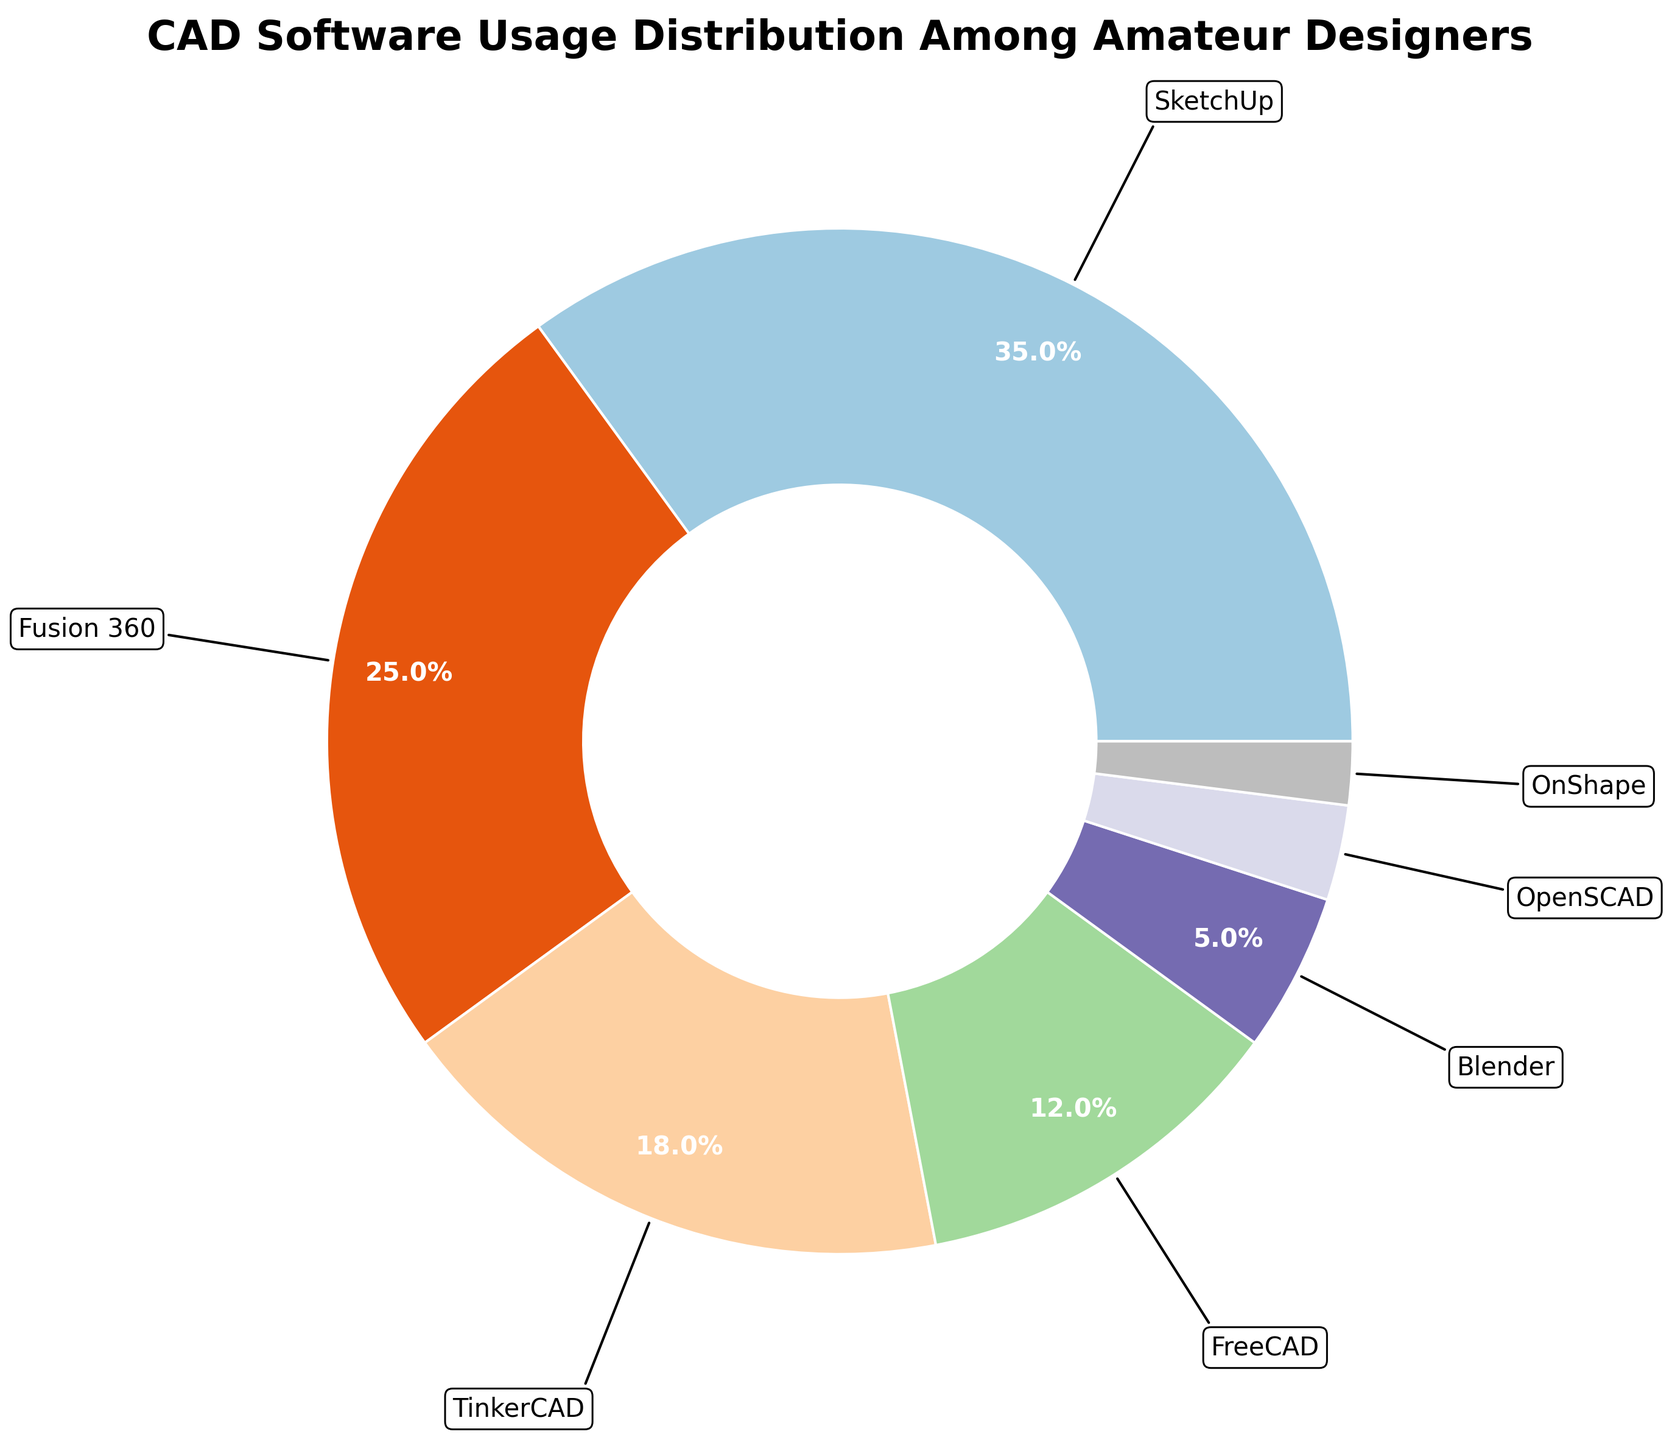How much higher is the percentage of SketchUp users than Blender users? To find out how much higher the SketchUp percentage is than the Blender percentage, subtract Blender's percentage (5%) from SketchUp's percentage (35%). So, 35% - 5% = 30%.
Answer: 30% Which software has the lowest usage percentage among amateur designers? Identify the software with the smallest slice in the pie chart. The smallest slice is for OnShape, with a usage percentage of 2%.
Answer: OnShape What is the combined percentage usage of TinkerCAD and FreeCAD? Add the usage percentages of TinkerCAD and FreeCAD: 18% + 12% = 30%.
Answer: 30% How does the usage of Fusion 360 compare to that of SketchUp? Compare the percentages directly from the pie chart: Fusion 360 has a 25% usage, while SketchUp has a 35% usage. Fusion 360's usage is 10% less than SketchUp's.
Answer: Fusion 360 is 10% less Is the usage of FreeCAD greater than OpenSCAD and OnShape combined? First, calculate the combined percentage of OpenSCAD and OnShape: 3% + 2% = 5%. Then compare it to FreeCAD's 12%. Since 12% is greater than 5%, FreeCAD's usage is indeed higher.
Answer: Yes What is the total percentage usage of software other than SketchUp and Fusion 360? Subtract the combined percentage of SketchUp and Fusion 360 from 100%. So, 100% - (35% + 25%) = 100% - 60% = 40%.
Answer: 40% How does Blender's usage percentage compare to TinkerCAD's? Refer to their respective percentages from the pie chart: Blender has 5% usage, TinkerCAD has 18%. Blender's usage is 13% less than TinkerCAD's.
Answer: Blender is 13% less What percentage of software users use either FreeCAD or OnShape? Add FreeCAD's and OnShape's usage percentages together: 12% + 2% = 14%.
Answer: 14% If Fusion 360 and TinkerCAD were combined into one software, what would their combined usage percentage be? Add the usage percentages of Fusion 360 and TinkerCAD: 25% + 18% = 43%.
Answer: 43% What is the average usage percentage of the three least popular software? Identify the three least popular software (OpenSCAD, OnShape, and Blender) and calculate their average percentage: (3% + 2% + 5%) / 3 = 10% / 3 ≈ 3.33%.
Answer: 3.33% 